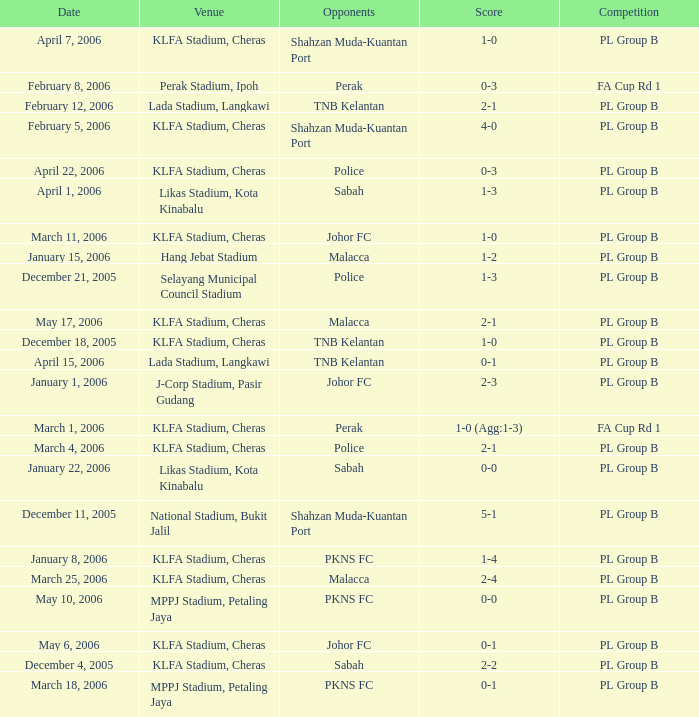Which Competition has a Score of 0-1, and Opponents of pkns fc? PL Group B. 